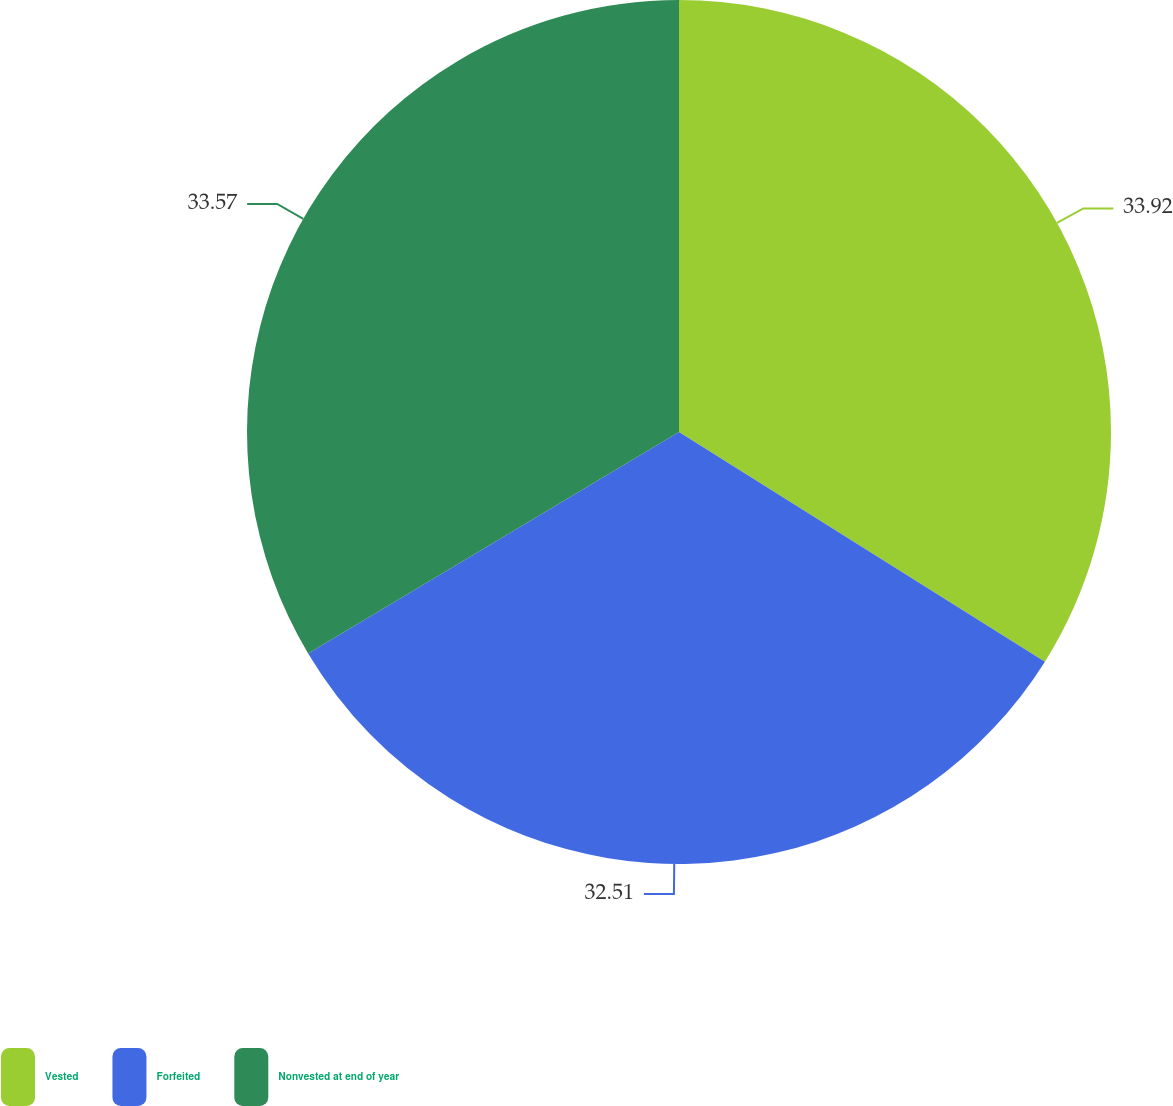Convert chart. <chart><loc_0><loc_0><loc_500><loc_500><pie_chart><fcel>Vested<fcel>Forfeited<fcel>Nonvested at end of year<nl><fcel>33.92%<fcel>32.51%<fcel>33.57%<nl></chart> 